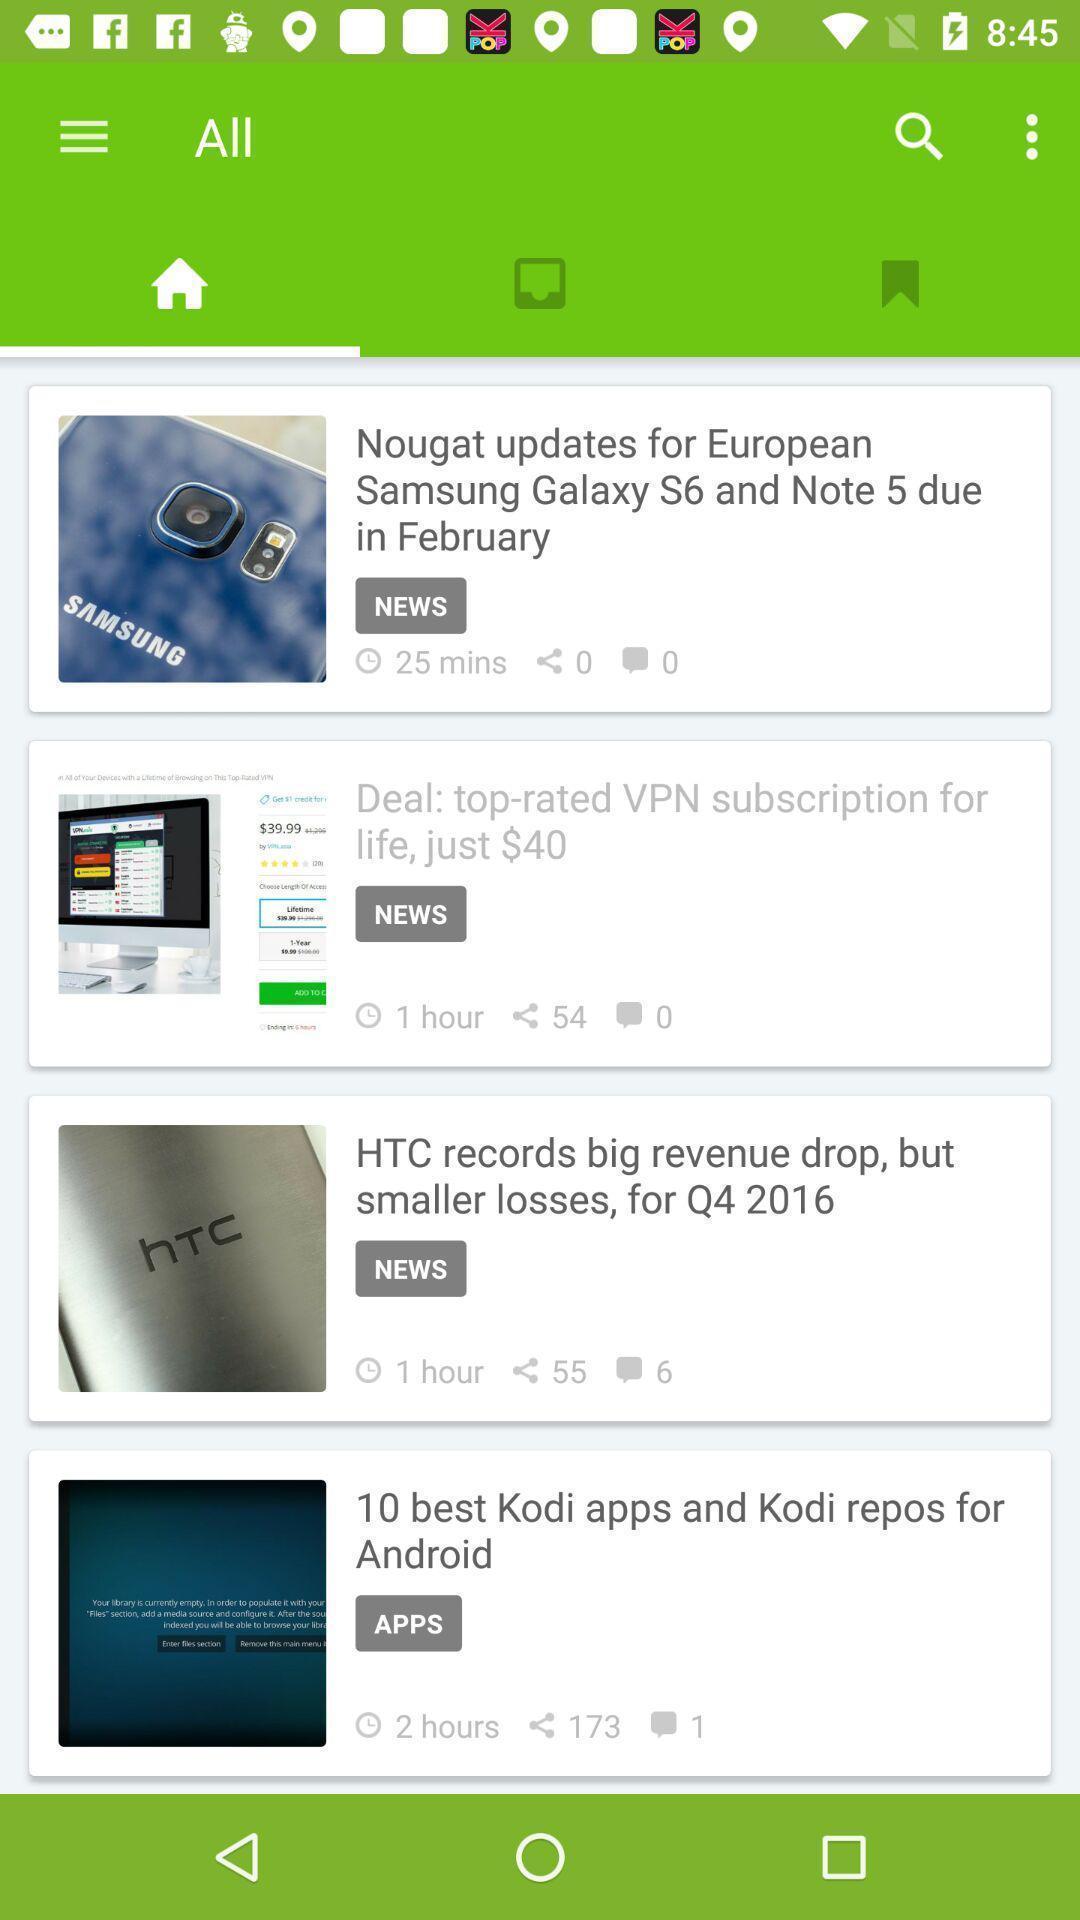Provide a description of this screenshot. Screen displaying home page. 